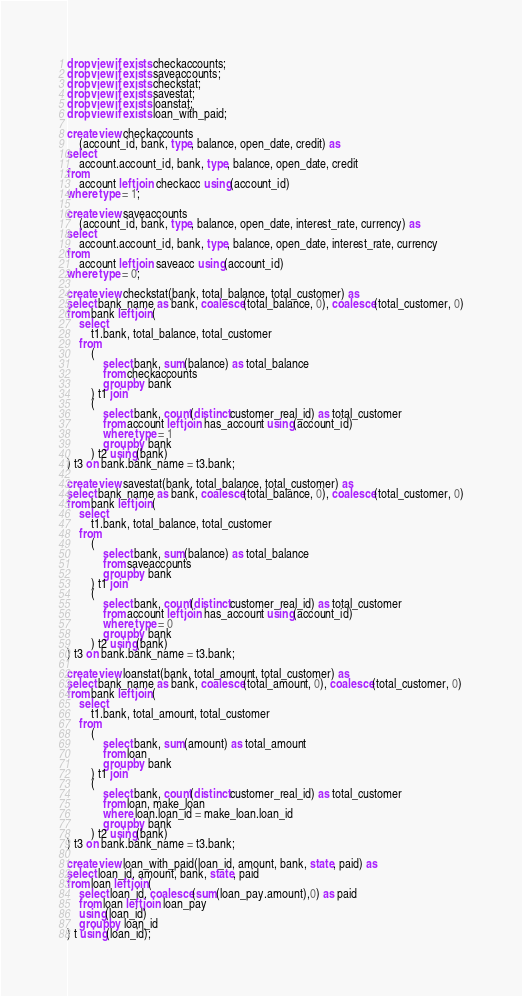<code> <loc_0><loc_0><loc_500><loc_500><_SQL_>drop view if exists checkaccounts;
drop view if exists saveaccounts;
drop view if exists checkstat;
drop view if exists savestat;
drop view if exists loanstat;
drop view if exists loan_with_paid;

create view checkaccounts
    (account_id, bank, type, balance, open_date, credit) as
select
    account.account_id, bank, type, balance, open_date, credit
from
    account left join checkacc using(account_id)
where type = 1;

create view saveaccounts
    (account_id, bank, type, balance, open_date, interest_rate, currency) as
select
    account.account_id, bank, type, balance, open_date, interest_rate, currency
from
    account left join saveacc using(account_id)
where type = 0;

create view checkstat(bank, total_balance, total_customer) as
select bank_name as bank, coalesce(total_balance, 0), coalesce(total_customer, 0)
from bank left join(
    select
        t1.bank, total_balance, total_customer
    from
        (
            select bank, sum(balance) as total_balance
            from checkaccounts
            group by bank
        ) t1 join
        (
            select bank, count(distinct customer_real_id) as total_customer
            from account left join has_account using(account_id)
            where type = 1
            group by bank
        ) t2 using(bank)
) t3 on bank.bank_name = t3.bank;

create view savestat(bank, total_balance, total_customer) as
select bank_name as bank, coalesce(total_balance, 0), coalesce(total_customer, 0)
from bank left join(
    select
        t1.bank, total_balance, total_customer
    from
        (
            select bank, sum(balance) as total_balance
            from saveaccounts
            group by bank
        ) t1 join
        (
            select bank, count(distinct customer_real_id) as total_customer
            from account left join has_account using(account_id)
            where type = 0
            group by bank
        ) t2 using(bank)
) t3 on bank.bank_name = t3.bank;

create view loanstat(bank, total_amount, total_customer) as
select bank_name as bank, coalesce(total_amount, 0), coalesce(total_customer, 0)
from bank left join(
    select
        t1.bank, total_amount, total_customer
    from
        (
            select bank, sum(amount) as total_amount
            from loan
            group by bank
        ) t1 join
        (
            select bank, count(distinct customer_real_id) as total_customer
            from loan, make_loan
            where loan.loan_id = make_loan.loan_id
            group by bank
        ) t2 using(bank)
) t3 on bank.bank_name = t3.bank;

create view loan_with_paid(loan_id, amount, bank, state, paid) as
select loan_id, amount, bank, state, paid
from loan left join(
    select loan_id, coalesce(sum(loan_pay.amount),0) as paid
    from loan left join loan_pay
    using(loan_id)
    group by loan_id
) t using(loan_id);
</code> 